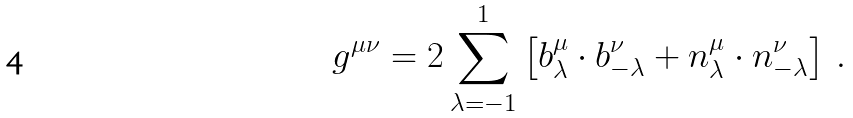Convert formula to latex. <formula><loc_0><loc_0><loc_500><loc_500>g ^ { \mu \nu } = 2 \sum _ { \lambda = - 1 } ^ { 1 } \left [ b _ { \lambda } ^ { \mu } \cdot b _ { - \lambda } ^ { \nu } + n _ { \lambda } ^ { \mu } \cdot n _ { - \lambda } ^ { \nu } \right ] \, .</formula> 